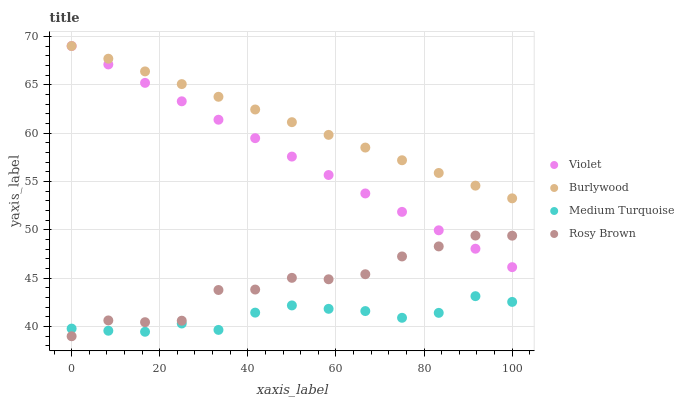Does Medium Turquoise have the minimum area under the curve?
Answer yes or no. Yes. Does Burlywood have the maximum area under the curve?
Answer yes or no. Yes. Does Rosy Brown have the minimum area under the curve?
Answer yes or no. No. Does Rosy Brown have the maximum area under the curve?
Answer yes or no. No. Is Burlywood the smoothest?
Answer yes or no. Yes. Is Rosy Brown the roughest?
Answer yes or no. Yes. Is Medium Turquoise the smoothest?
Answer yes or no. No. Is Medium Turquoise the roughest?
Answer yes or no. No. Does Rosy Brown have the lowest value?
Answer yes or no. Yes. Does Medium Turquoise have the lowest value?
Answer yes or no. No. Does Violet have the highest value?
Answer yes or no. Yes. Does Rosy Brown have the highest value?
Answer yes or no. No. Is Rosy Brown less than Burlywood?
Answer yes or no. Yes. Is Burlywood greater than Rosy Brown?
Answer yes or no. Yes. Does Rosy Brown intersect Medium Turquoise?
Answer yes or no. Yes. Is Rosy Brown less than Medium Turquoise?
Answer yes or no. No. Is Rosy Brown greater than Medium Turquoise?
Answer yes or no. No. Does Rosy Brown intersect Burlywood?
Answer yes or no. No. 